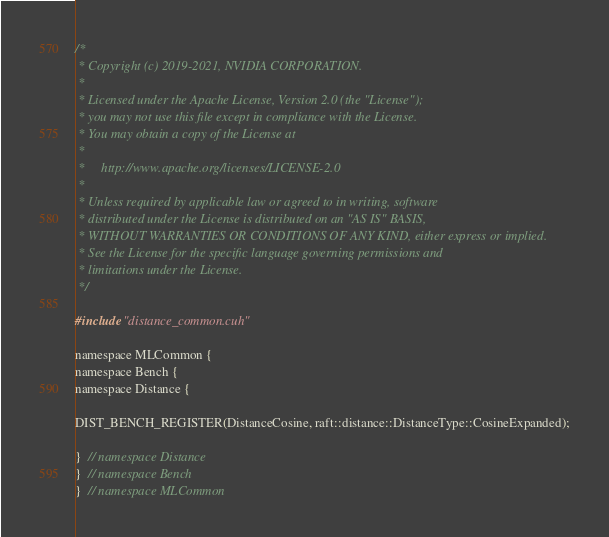<code> <loc_0><loc_0><loc_500><loc_500><_Cuda_>/*
 * Copyright (c) 2019-2021, NVIDIA CORPORATION.
 *
 * Licensed under the Apache License, Version 2.0 (the "License");
 * you may not use this file except in compliance with the License.
 * You may obtain a copy of the License at
 *
 *     http://www.apache.org/licenses/LICENSE-2.0
 *
 * Unless required by applicable law or agreed to in writing, software
 * distributed under the License is distributed on an "AS IS" BASIS,
 * WITHOUT WARRANTIES OR CONDITIONS OF ANY KIND, either express or implied.
 * See the License for the specific language governing permissions and
 * limitations under the License.
 */

#include "distance_common.cuh"

namespace MLCommon {
namespace Bench {
namespace Distance {

DIST_BENCH_REGISTER(DistanceCosine, raft::distance::DistanceType::CosineExpanded);

}  // namespace Distance
}  // namespace Bench
}  // namespace MLCommon
</code> 